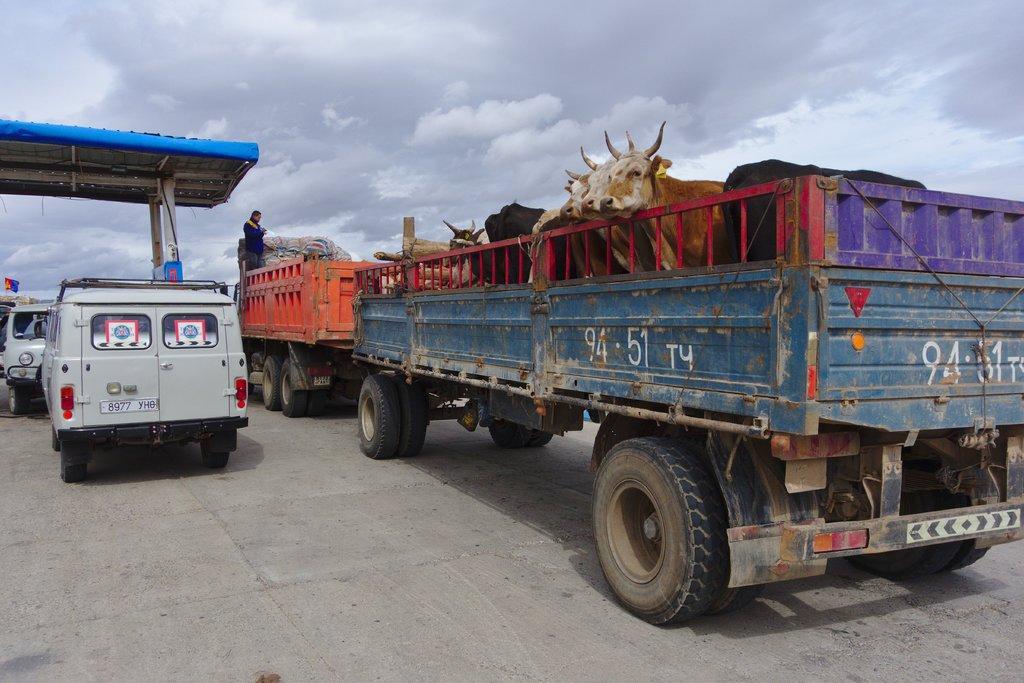Can you describe this image briefly? In this picture I can see the road on which there are number of vehicles and on the right side of this picture I can see a trolley, on which there are animals and on the top of this picture I can see the shed and the cloudy sky. I can also see a person. 